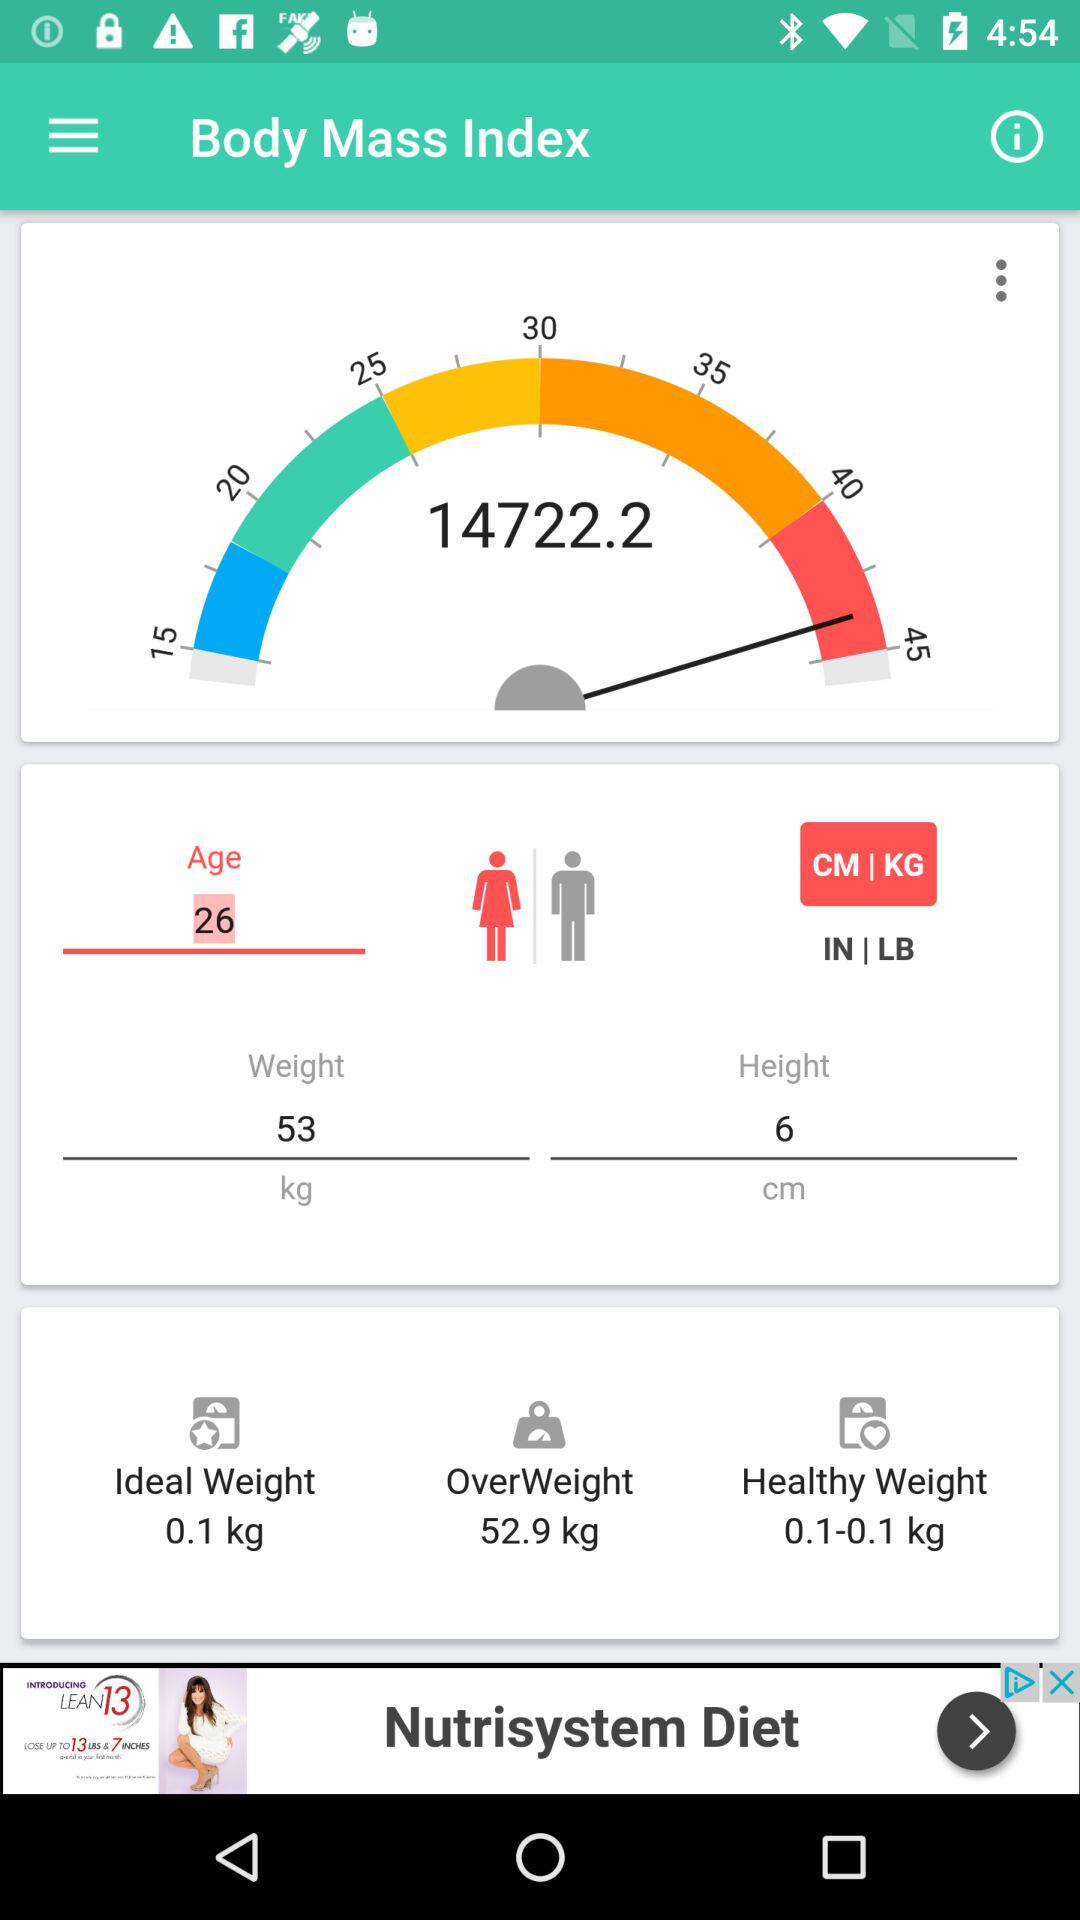What is the given height? The given height is 6 cm. 